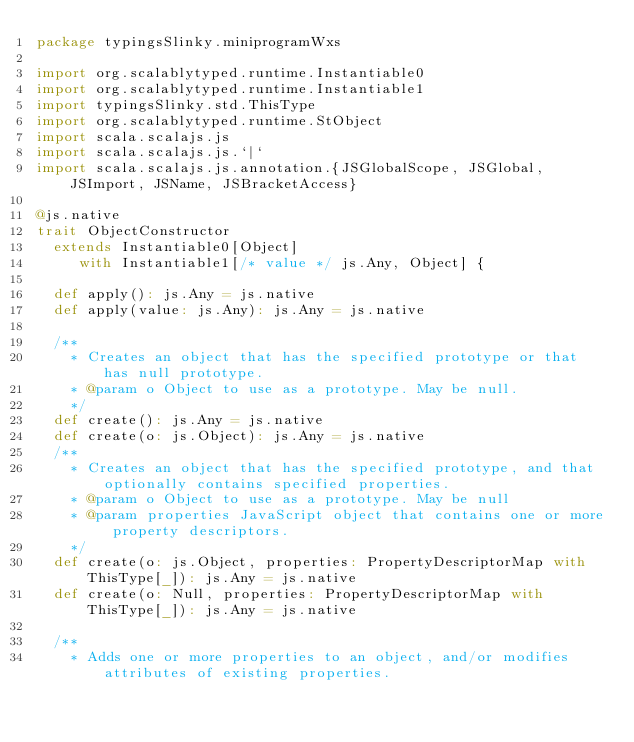Convert code to text. <code><loc_0><loc_0><loc_500><loc_500><_Scala_>package typingsSlinky.miniprogramWxs

import org.scalablytyped.runtime.Instantiable0
import org.scalablytyped.runtime.Instantiable1
import typingsSlinky.std.ThisType
import org.scalablytyped.runtime.StObject
import scala.scalajs.js
import scala.scalajs.js.`|`
import scala.scalajs.js.annotation.{JSGlobalScope, JSGlobal, JSImport, JSName, JSBracketAccess}

@js.native
trait ObjectConstructor
  extends Instantiable0[Object]
     with Instantiable1[/* value */ js.Any, Object] {
  
  def apply(): js.Any = js.native
  def apply(value: js.Any): js.Any = js.native
  
  /**
    * Creates an object that has the specified prototype or that has null prototype.
    * @param o Object to use as a prototype. May be null.
    */
  def create(): js.Any = js.native
  def create(o: js.Object): js.Any = js.native
  /**
    * Creates an object that has the specified prototype, and that optionally contains specified properties.
    * @param o Object to use as a prototype. May be null
    * @param properties JavaScript object that contains one or more property descriptors.
    */
  def create(o: js.Object, properties: PropertyDescriptorMap with ThisType[_]): js.Any = js.native
  def create(o: Null, properties: PropertyDescriptorMap with ThisType[_]): js.Any = js.native
  
  /**
    * Adds one or more properties to an object, and/or modifies attributes of existing properties.</code> 